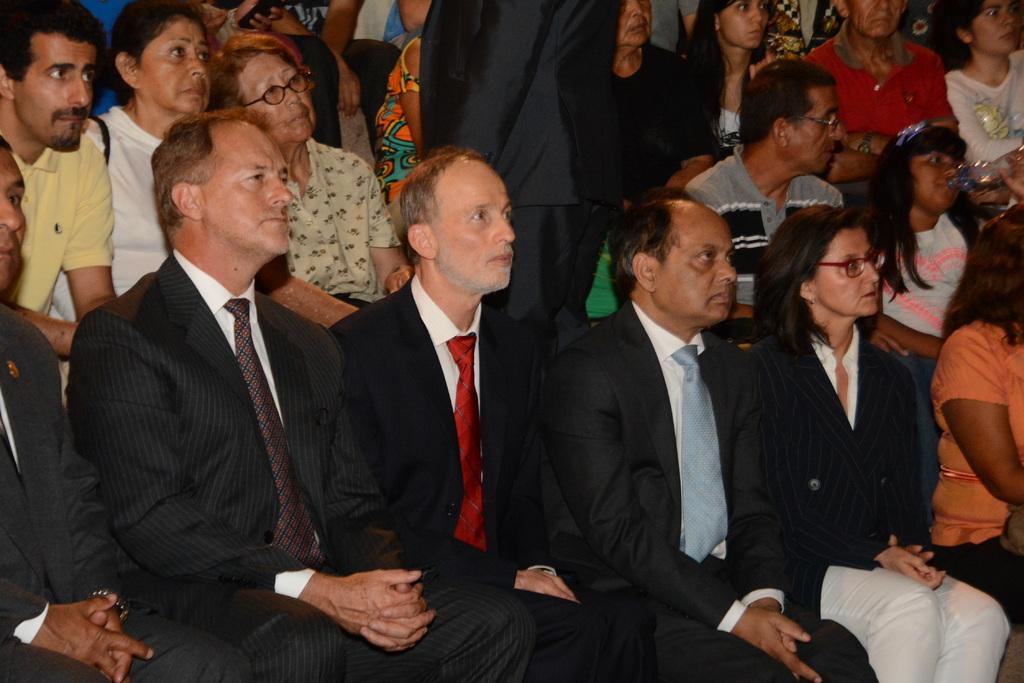What are the people in the image doing? There are persons sitting on chairs in the image, and one person is standing in the middle. Can you describe the girl in the image? The girl in the image is present, and she is drinking water. What type of thrill can be seen in the image? There is no thrill present in the image; it features people sitting on chairs, a person standing, and a girl drinking water. Can you describe the kettle in the image? There is no kettle present in the image. 